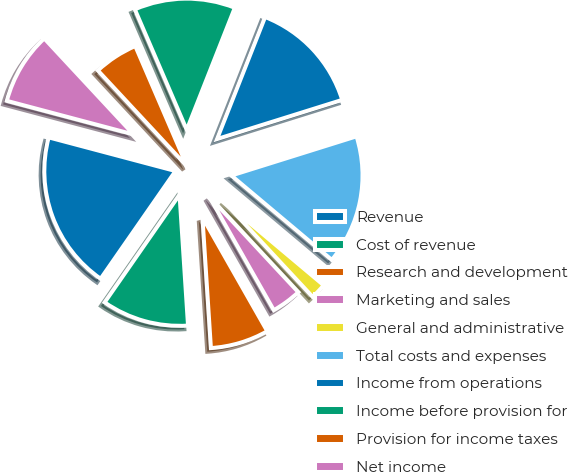Convert chart to OTSL. <chart><loc_0><loc_0><loc_500><loc_500><pie_chart><fcel>Revenue<fcel>Cost of revenue<fcel>Research and development<fcel>Marketing and sales<fcel>General and administrative<fcel>Total costs and expenses<fcel>Income from operations<fcel>Income before provision for<fcel>Provision for income taxes<fcel>Net income<nl><fcel>19.46%<fcel>10.7%<fcel>7.2%<fcel>3.7%<fcel>1.95%<fcel>15.95%<fcel>14.2%<fcel>12.45%<fcel>5.45%<fcel>8.95%<nl></chart> 